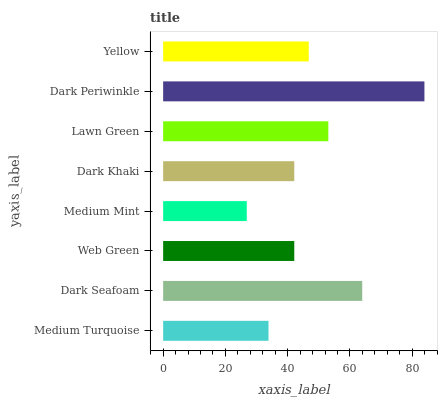Is Medium Mint the minimum?
Answer yes or no. Yes. Is Dark Periwinkle the maximum?
Answer yes or no. Yes. Is Dark Seafoam the minimum?
Answer yes or no. No. Is Dark Seafoam the maximum?
Answer yes or no. No. Is Dark Seafoam greater than Medium Turquoise?
Answer yes or no. Yes. Is Medium Turquoise less than Dark Seafoam?
Answer yes or no. Yes. Is Medium Turquoise greater than Dark Seafoam?
Answer yes or no. No. Is Dark Seafoam less than Medium Turquoise?
Answer yes or no. No. Is Yellow the high median?
Answer yes or no. Yes. Is Web Green the low median?
Answer yes or no. Yes. Is Dark Seafoam the high median?
Answer yes or no. No. Is Lawn Green the low median?
Answer yes or no. No. 